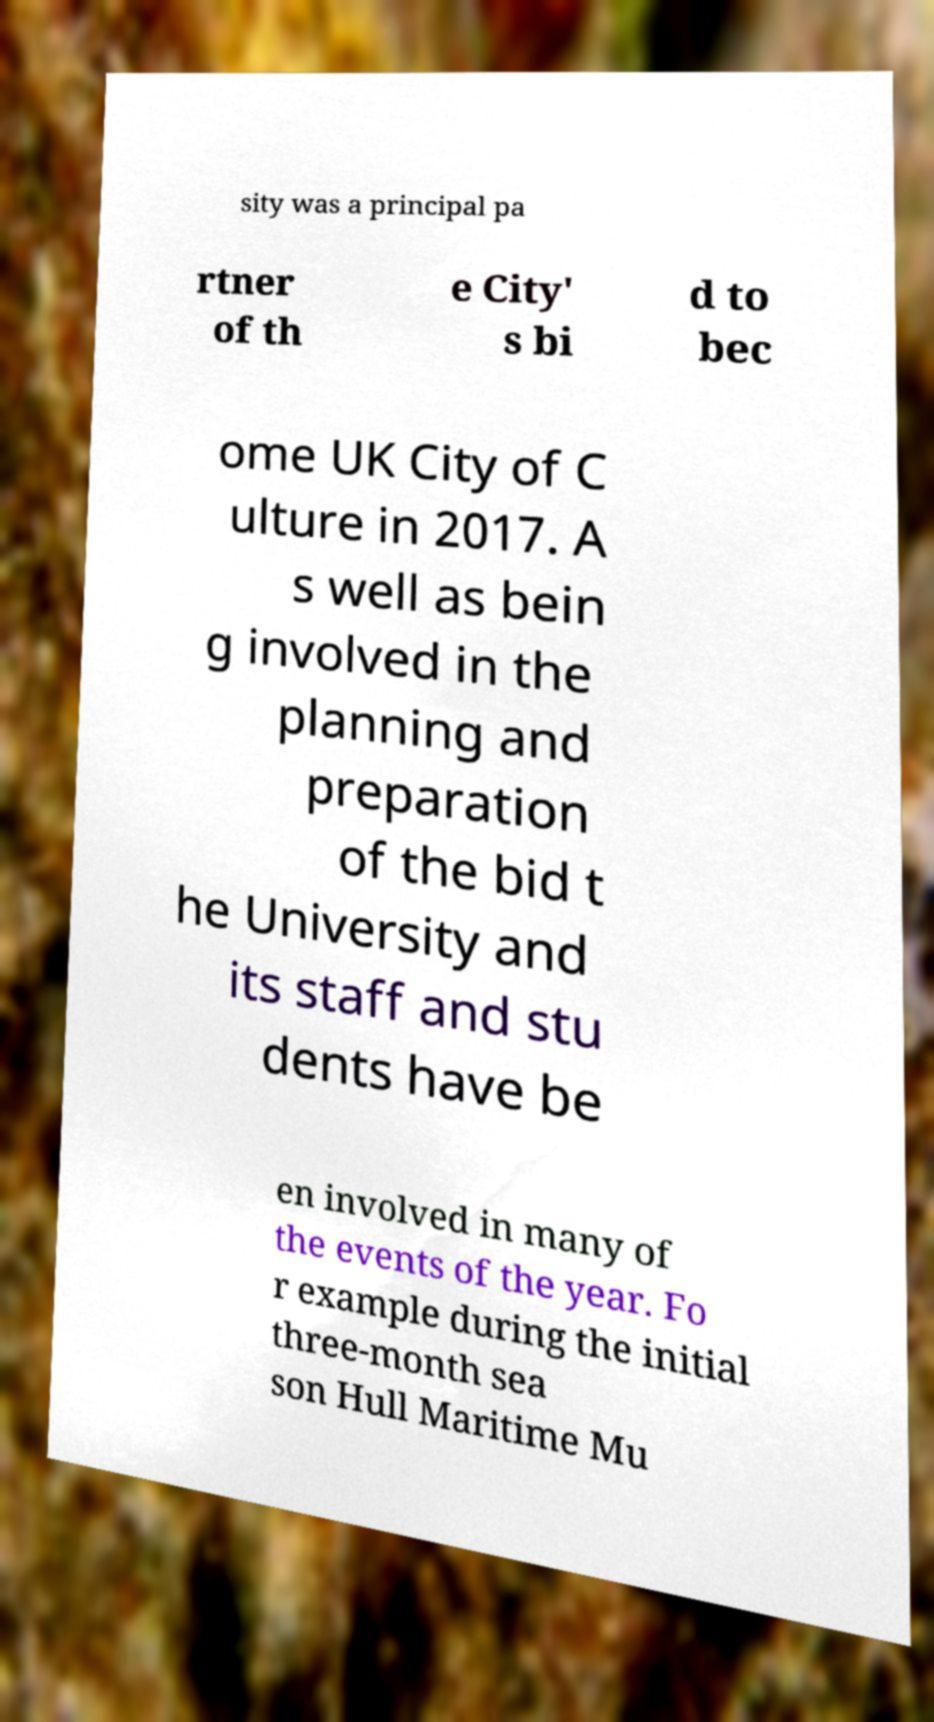For documentation purposes, I need the text within this image transcribed. Could you provide that? sity was a principal pa rtner of th e City' s bi d to bec ome UK City of C ulture in 2017. A s well as bein g involved in the planning and preparation of the bid t he University and its staff and stu dents have be en involved in many of the events of the year. Fo r example during the initial three-month sea son Hull Maritime Mu 